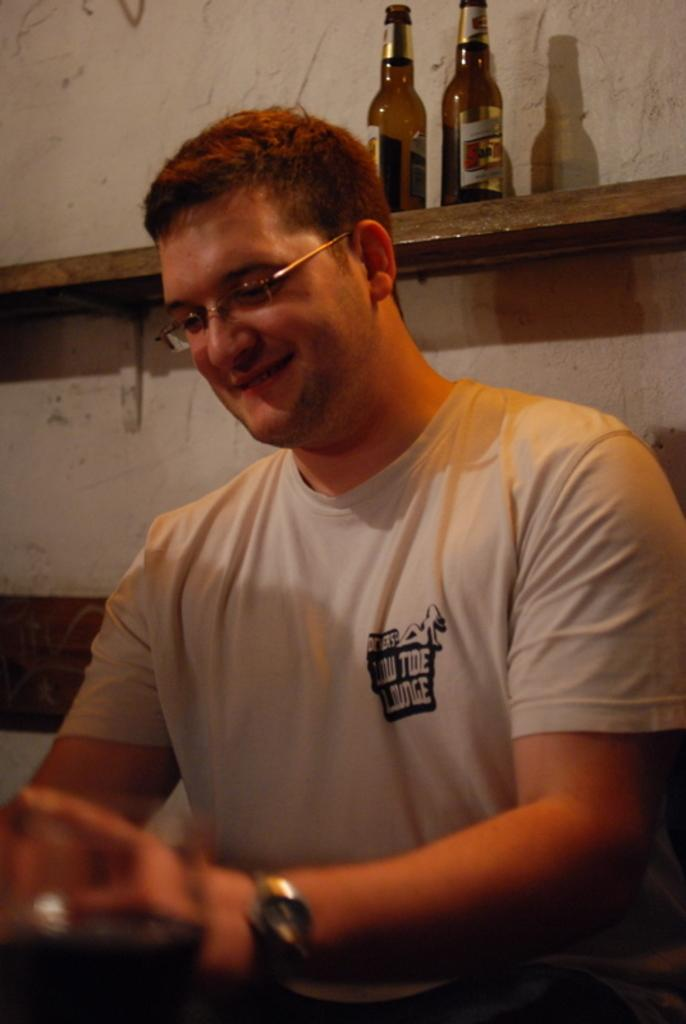Where was the image taken? The image was taken indoors. What can be seen in the background of the image? There is a wall and a shelf with two bottles in the background. Who is the main subject in the image? There is a man in the middle of the image. What is the man's facial expression? The man has a smiling face. What type of school can be seen in the background of the image? There is no school present in the image; it was taken indoors with a wall and a shelf with two bottles in the background. 